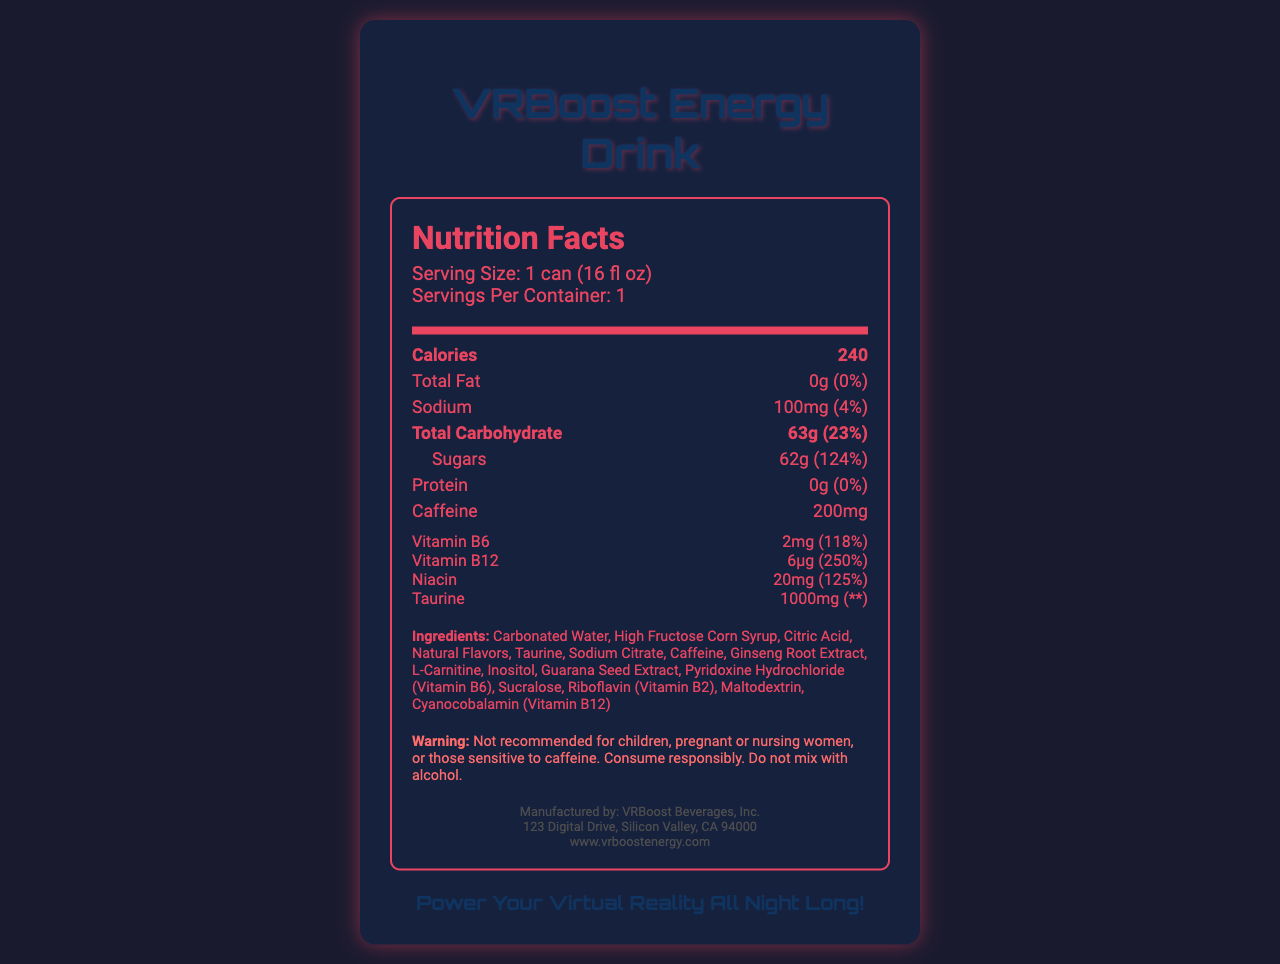what is the serving size? The serving size is directly stated in the serving information section.
Answer: 1 can (16 fl oz) how many calories are in one serving of VRBoost Energy Drink? The calories are listed prominently under the bold "Calories" section.
Answer: 240 what is the amount of sugar in one serving? The amount of sugar is specified under the "Sugars" section.
Answer: 62g how much caffeine does one can contain? The caffeine content is listed directly in the nutrient section.
Answer: 200mg what percentage of daily value does sodium cover? The daily value percentage for sodium is stated next to its amount.
Answer: 4% which vitamin is present in the highest daily value percentage? A. Vitamin B6 B. Vitamin B12 C. Niacin D. Taurine Vitamin B12 has a daily value percentage of 250%, the highest among the listed vitamins and minerals.
Answer: B. Vitamin B12 how many grams of total carbohydrate are in one can? The total carbohydrate amount is listed under the bold "Total Carbohydrate" section.
Answer: 63g what are the first three ingredients listed? The ingredients are listed in descending order of quantity, and the first three are mentioned as Carbonated Water, High Fructose Corn Syrup, and Citric Acid.
Answer: Carbonated Water, High Fructose Corn Syrup, Citric Acid how much protein is in one serving? The protein amount is listed in the nutrient section as 0g.
Answer: 0g is VRBoost Energy Drink recommended for children? The warning section clearly states that it is not recommended for children.
Answer: No what is the daily value percentage for Vitamin B6? The daily value percentage for Vitamin B6 is provided in the vitamins and minerals section.
Answer: 118% which vitamin has an amount labeled in micrograms (μg)? Vitamin B12 is listed with an amount of 6μg in the vitamins and minerals section.
Answer: Vitamin B12 what is the slogan of VRBoost Energy Drink? The slogan is mentioned at the bottom of the document under the "slogan" section.
Answer: Power Your Virtual Reality All Night Long! what should you not mix VRBoost Energy Drink with? A. Water B. Alcohol C. Juice D. Coffee The warning section explicitly states not to mix the drink with alcohol.
Answer: B. Alcohol what are some of the vitamins and their daily value percentages included in VRBoost Energy Drink? The vitamins and their daily value percentages are listed in the vitamins and minerals section.
Answer: Vitamin B6 - 118%, Vitamin B12 - 250%, Niacin - 125% what is the name of the manufacturer of VRBoost Energy Drink? The manufacturer's name is mentioned under the footer section at the end of the document.
Answer: VRBoost Beverages, Inc. is it safe for pregnant women to consume VRBoost Energy Drink? The warning section advises that it is not recommended for pregnant women.
Answer: No what is the main idea of the document? The document primarily serves to inform consumers about the nutritional content, ingredient list, and safe consumption practices of the VRBoost Energy Drink.
Answer: The document provides detailed nutrition facts, ingredients, and safety warnings for VRBoost Energy Drink. It includes serving size, calories, amounts of various nutrients and vitamins, and a caution about consumption. what flavor is VRBoost Energy Drink? The document does not provide any information about the flavor of the VRBoost Energy Drink.
Answer: Not enough information 